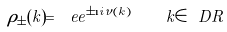Convert formula to latex. <formula><loc_0><loc_0><loc_500><loc_500>\rho _ { \pm } ( k ) = \ e e ^ { \pm \i i \nu ( k ) } \quad k \in \ D { R }</formula> 